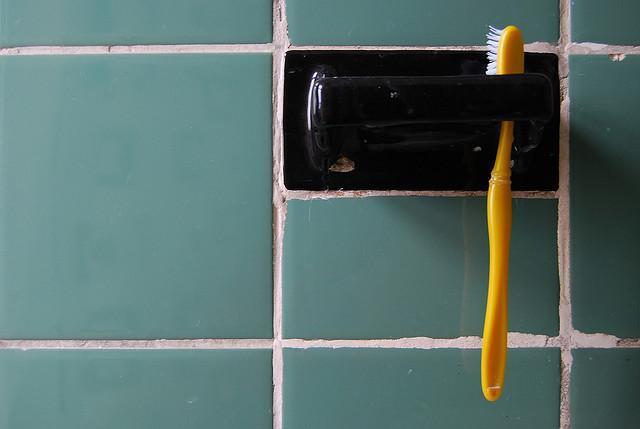How many people are in the bathroom?
Give a very brief answer. 0. 